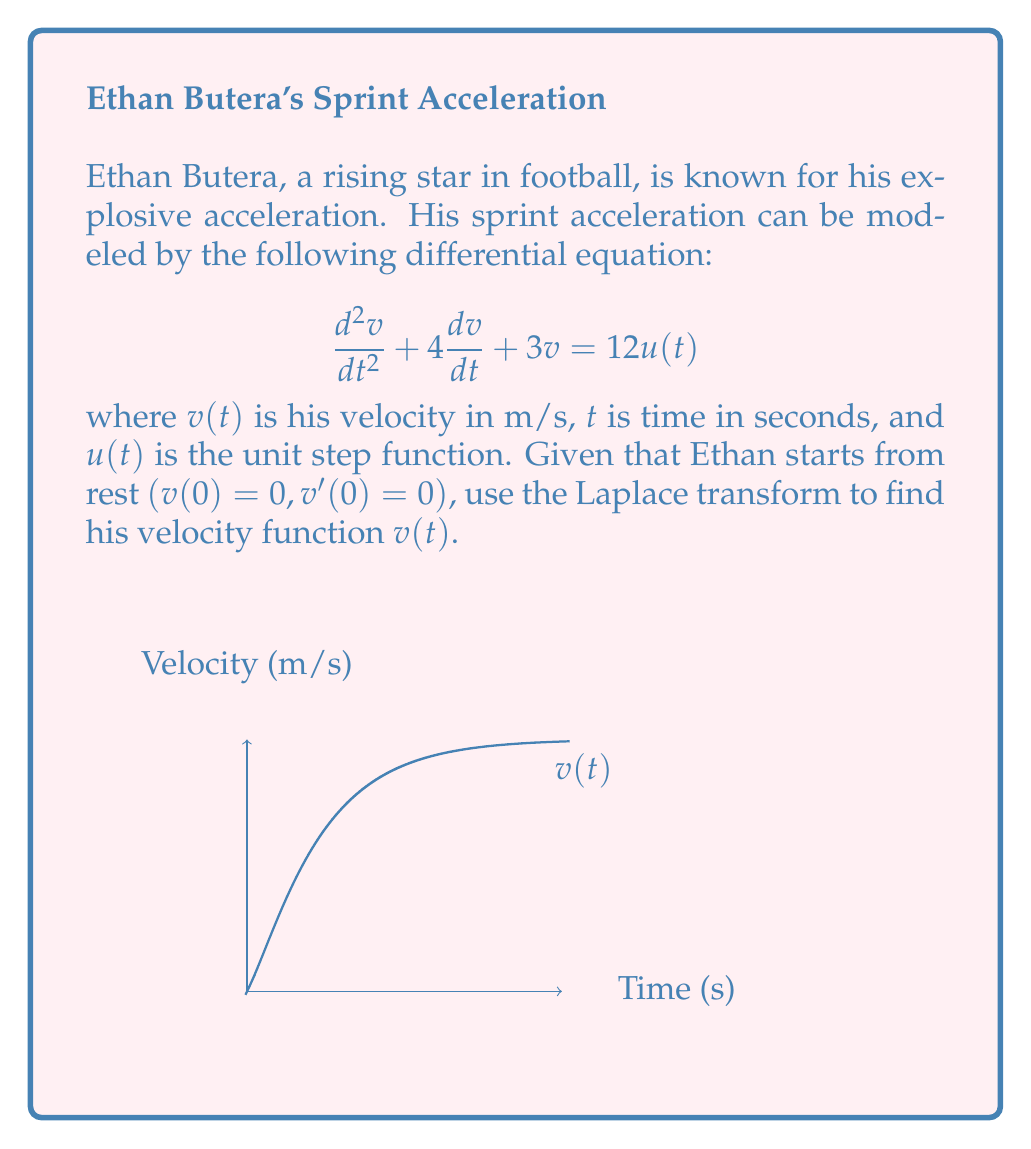Give your solution to this math problem. Let's solve this step-by-step using Laplace transforms:

1) Take the Laplace transform of both sides of the equation:
   $$\mathcal{L}\{d^2v/dt^2\} + 4\mathcal{L}\{dv/dt\} + 3\mathcal{L}\{v\} = 12\mathcal{L}\{u(t)\}$$

2) Using Laplace transform properties:
   $$(s^2V(s) - sv(0) - v'(0)) + 4(sV(s) - v(0)) + 3V(s) = 12/s$$

3) Substitute initial conditions $(v(0) = 0, v'(0) = 0)$:
   $$s^2V(s) + 4sV(s) + 3V(s) = 12/s$$

4) Factor out $V(s)$:
   $$V(s)(s^2 + 4s + 3) = 12/s$$

5) Solve for $V(s)$:
   $$V(s) = \frac{12}{s(s^2 + 4s + 3)} = \frac{12}{s(s+1)(s+3)}$$

6) Perform partial fraction decomposition:
   $$V(s) = \frac{A}{s} + \frac{B}{s+1} + \frac{C}{s+3}$$

7) Solve for A, B, and C:
   $$A = 4, B = -5, C = 1$$

8) Rewrite $V(s)$:
   $$V(s) = \frac{4}{s} - \frac{5}{s+1} + \frac{1}{s+3}$$

9) Take the inverse Laplace transform:
   $$v(t) = 4\mathcal{L}^{-1}\{\frac{1}{s}\} - 5\mathcal{L}^{-1}\{\frac{1}{s+1}\} + \mathcal{L}^{-1}\{\frac{1}{s+3}\}$$

10) Simplify:
    $$v(t) = 4 - 5e^{-t} + e^{-3t}$$
Answer: $v(t) = 4 - 5e^{-t} + e^{-3t}$ 